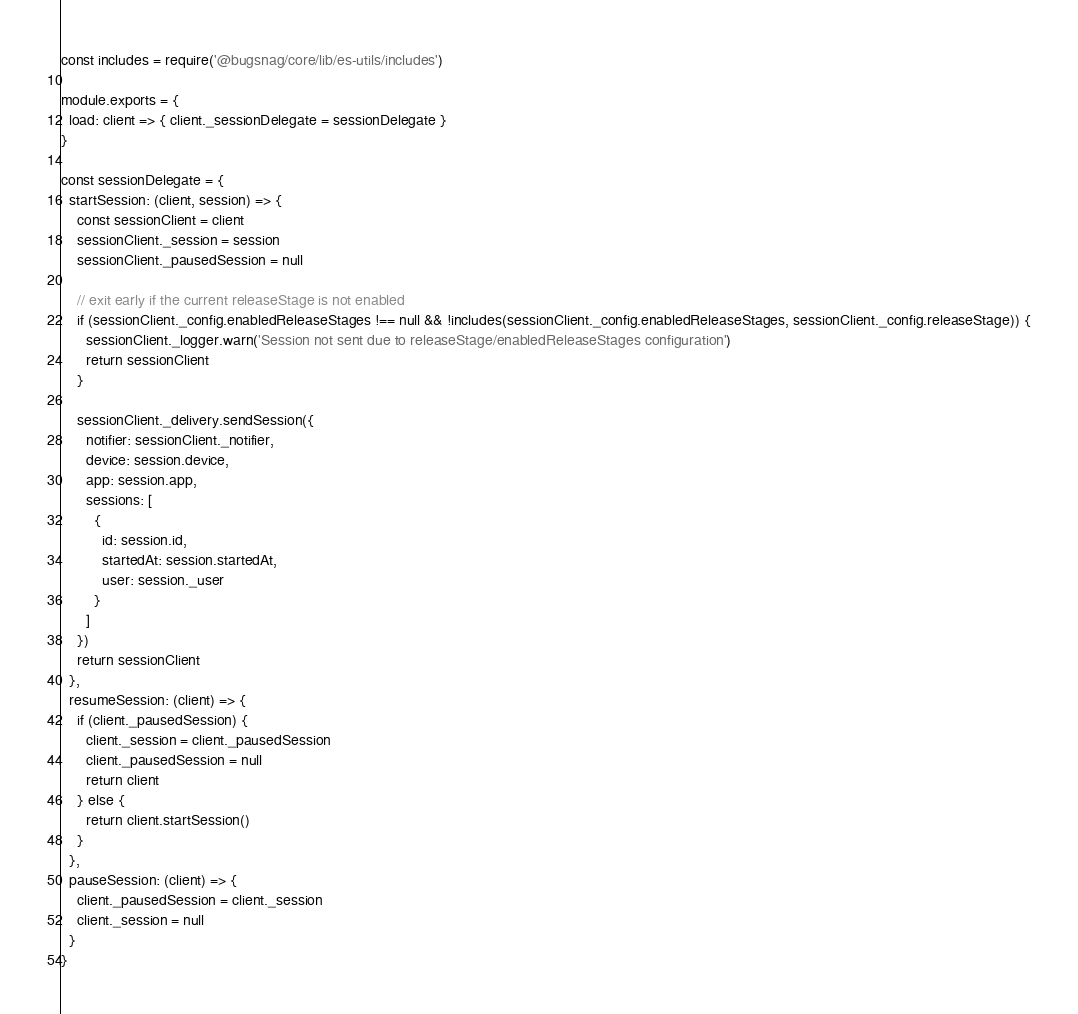<code> <loc_0><loc_0><loc_500><loc_500><_JavaScript_>const includes = require('@bugsnag/core/lib/es-utils/includes')

module.exports = {
  load: client => { client._sessionDelegate = sessionDelegate }
}

const sessionDelegate = {
  startSession: (client, session) => {
    const sessionClient = client
    sessionClient._session = session
    sessionClient._pausedSession = null

    // exit early if the current releaseStage is not enabled
    if (sessionClient._config.enabledReleaseStages !== null && !includes(sessionClient._config.enabledReleaseStages, sessionClient._config.releaseStage)) {
      sessionClient._logger.warn('Session not sent due to releaseStage/enabledReleaseStages configuration')
      return sessionClient
    }

    sessionClient._delivery.sendSession({
      notifier: sessionClient._notifier,
      device: session.device,
      app: session.app,
      sessions: [
        {
          id: session.id,
          startedAt: session.startedAt,
          user: session._user
        }
      ]
    })
    return sessionClient
  },
  resumeSession: (client) => {
    if (client._pausedSession) {
      client._session = client._pausedSession
      client._pausedSession = null
      return client
    } else {
      return client.startSession()
    }
  },
  pauseSession: (client) => {
    client._pausedSession = client._session
    client._session = null
  }
}
</code> 